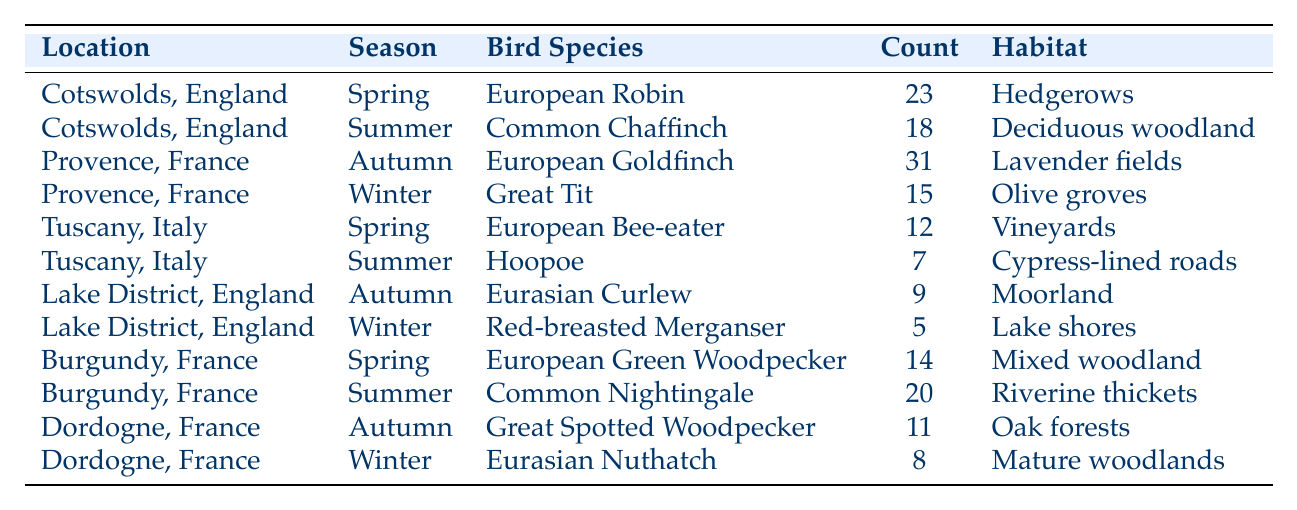What bird species was observed most frequently in Provence during Autumn? According to the table, the bird species observed in Provence during Autumn was the European Goldfinch, with a count of 31, which is the highest count for that location and season.
Answer: European Goldfinch What is the total count of bird species observed in Cotswolds, England across all seasons? The table shows a count of 23 for European Robin in Spring and a count of 18 for Common Chaffinch in Summer. Adding these gives 23 + 18 = 41, so the total count is 41.
Answer: 41 True or False: The Great Tit was observed in Provence during the Spring season. The table indicates that the Great Tit was observed in Provence during Winter, therefore the statement is false.
Answer: False Which location had the least number of bird sightings in Winter? The data reveals that the Lake District, England had the least number of bird sightings in Winter, specifically 5 sightings of the Red-breasted Merganser, while Dordogne had 8 sightings.
Answer: Lake District, England What is the average number of bird sightings for the Summer season across all locations? The summer counts from the table are 18 (Cotswolds), 20 (Burgundy), and 7 (Tuscany). Adding these gives 18 + 20 + 7 = 45. Since there are 3 locations, the average is 45 / 3 = 15.
Answer: 15 How many total observations were recorded in Tuscany? The table lists 12 observations of the European Bee-eater in Spring and 7 of the Hoopoe in Summer for Tuscany. Summing these gives 12 + 7 = 19.
Answer: 19 In which habitat was the Common Nightingale observed? The table shows that the Common Nightingale was observed in Riverine thickets which is listed under the Summer season for Burgundy.
Answer: Riverine thickets What is the highest bird count observed in any season across all locations? Looking at the data, the highest count is 31, observed with the European Goldfinch in Provence during Autumn, which is greater than any other count shown in the table.
Answer: 31 Which bird species is observed in the Lake District during Autumn? The table specifies that the Eurasian Curlew was observed in the Lake District during Autumn, with a count of 9.
Answer: Eurasian Curlew How does the count of birds in Burgundy during Summer compare to those in Tuscany during Summer? The count for Burgundy during Summer is 20 (Common Nightingale), while in Tuscany it is 7 (Hoopoe). 20 is greater than 7, indicating Burgundy had more sightings.
Answer: Burgundy had more sightings How many different bird species are listed for Spring across all locations? The table specifies 3 different bird species for Spring: European Robin in Cotswolds (23), European Bee-eater in Tuscany (12), and European Green Woodpecker in Burgundy (14). This results in a total of 3 different species in Spring.
Answer: 3 